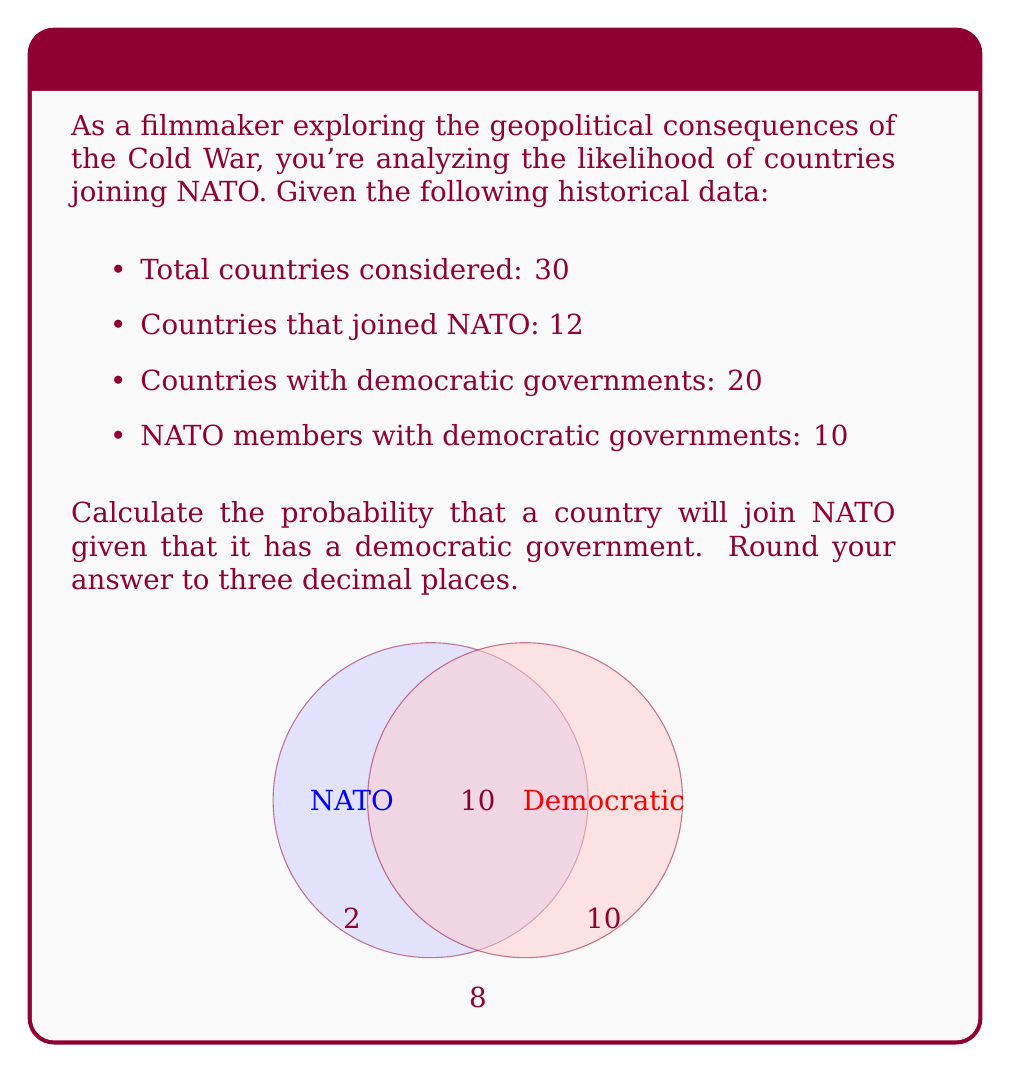Show me your answer to this math problem. To solve this problem, we'll use Bayes' theorem:

$$P(A|B) = \frac{P(B|A) \cdot P(A)}{P(B)}$$

Where:
A: Event of joining NATO
B: Event of having a democratic government

Step 1: Calculate P(A) - Probability of joining NATO
$$P(A) = \frac{12}{30} = 0.4$$

Step 2: Calculate P(B) - Probability of having a democratic government
$$P(B) = \frac{20}{30} = \frac{2}{3} \approx 0.667$$

Step 3: Calculate P(B|A) - Probability of having a democratic government given that a country joined NATO
$$P(B|A) = \frac{10}{12} \approx 0.833$$

Step 4: Apply Bayes' theorem
$$P(A|B) = \frac{P(B|A) \cdot P(A)}{P(B)} = \frac{0.833 \cdot 0.4}{0.667} \approx 0.500$$

Step 5: Round to three decimal places
$$P(A|B) \approx 0.500$$
Answer: 0.500 